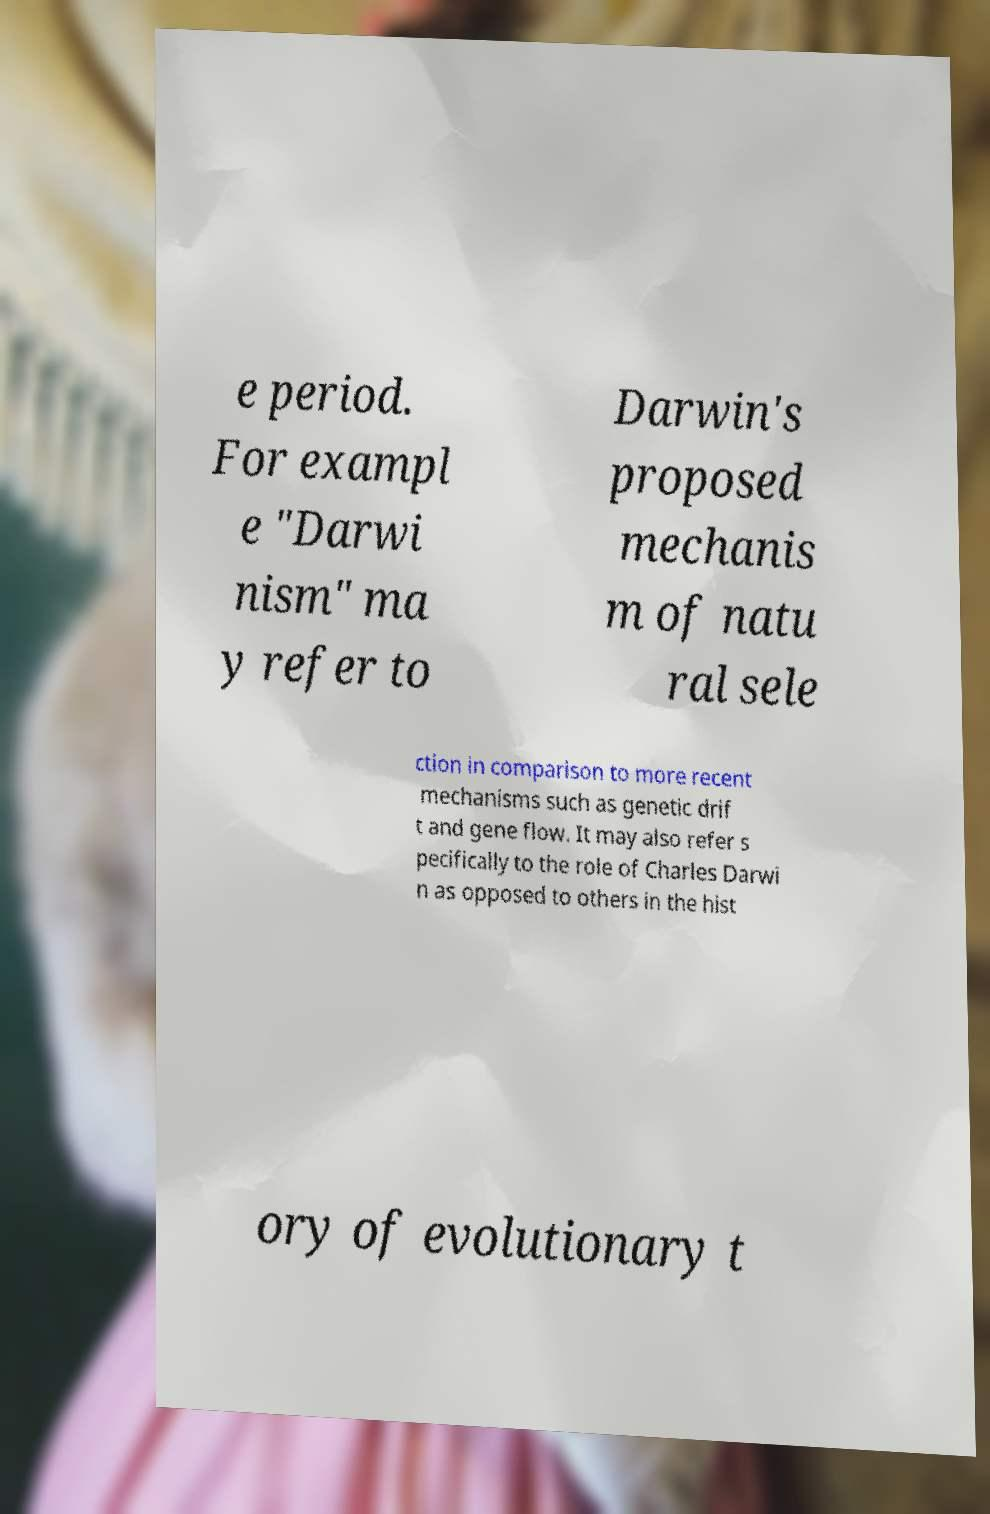For documentation purposes, I need the text within this image transcribed. Could you provide that? e period. For exampl e "Darwi nism" ma y refer to Darwin's proposed mechanis m of natu ral sele ction in comparison to more recent mechanisms such as genetic drif t and gene flow. It may also refer s pecifically to the role of Charles Darwi n as opposed to others in the hist ory of evolutionary t 